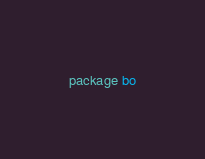<code> <loc_0><loc_0><loc_500><loc_500><_Go_>package bo
</code> 